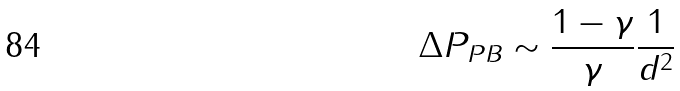<formula> <loc_0><loc_0><loc_500><loc_500>\Delta P _ { P B } \sim \frac { 1 - \gamma } { \gamma } \frac { 1 } { d ^ { 2 } }</formula> 